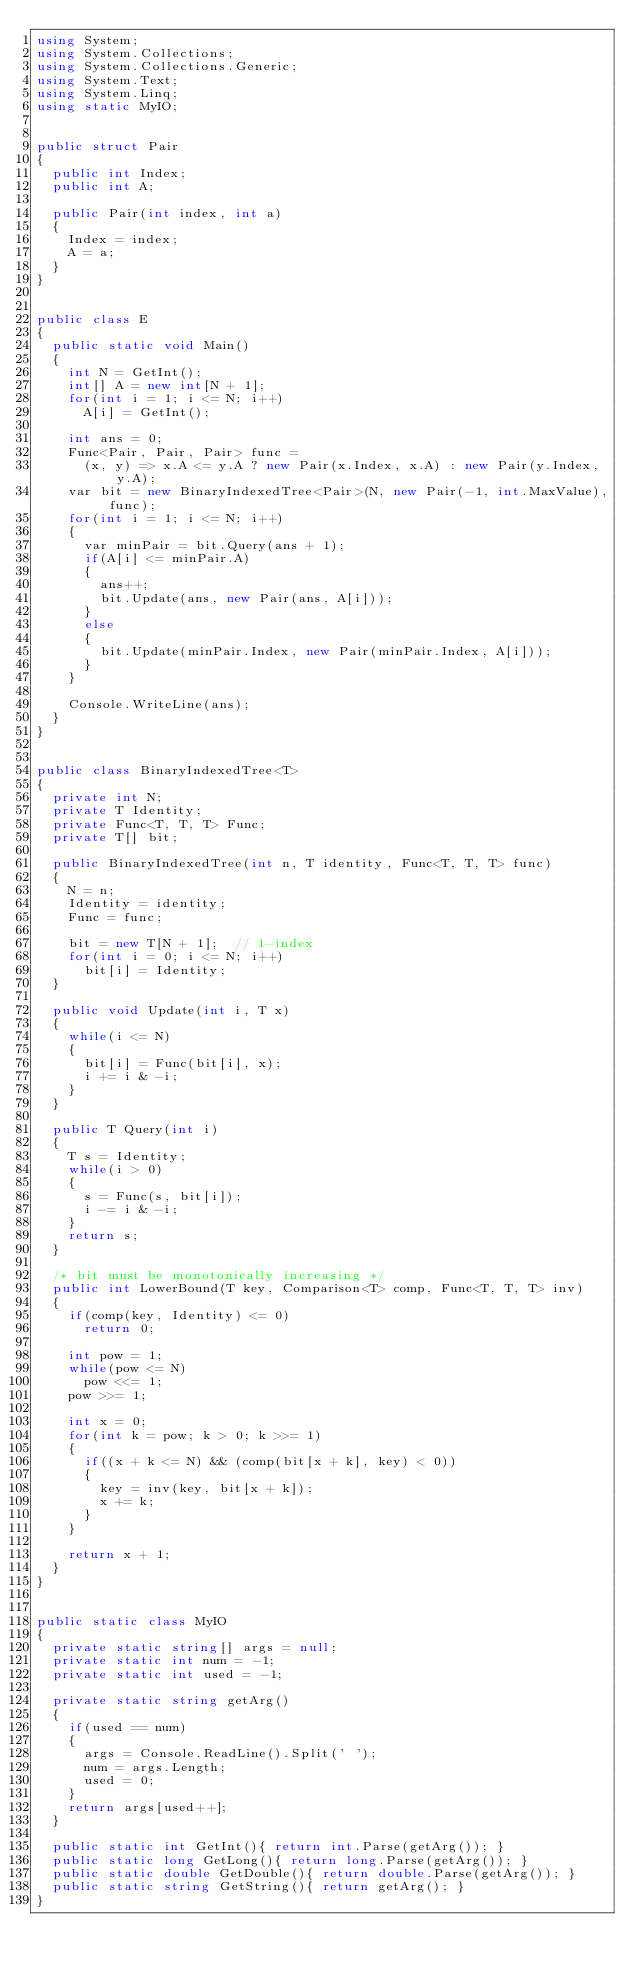Convert code to text. <code><loc_0><loc_0><loc_500><loc_500><_C#_>using System;
using System.Collections;
using System.Collections.Generic;
using System.Text;
using System.Linq;
using static MyIO;


public struct Pair
{
	public int Index;
	public int A;

	public Pair(int index, int a)
	{
		Index = index;
		A = a;
	}
}


public class E
{
	public static void Main()
	{
		int N = GetInt();
		int[] A = new int[N + 1];
		for(int i = 1; i <= N; i++)
			A[i] = GetInt();

		int ans = 0;
		Func<Pair, Pair, Pair> func = 
			(x, y) => x.A <= y.A ? new Pair(x.Index, x.A) : new Pair(y.Index, y.A);
		var bit = new BinaryIndexedTree<Pair>(N, new Pair(-1, int.MaxValue), func);
		for(int i = 1; i <= N; i++)
		{
			var minPair = bit.Query(ans + 1);
			if(A[i] <= minPair.A)
			{
				ans++;
				bit.Update(ans, new Pair(ans, A[i]));
			}
			else
			{
				bit.Update(minPair.Index, new Pair(minPair.Index, A[i]));
			}
		}

		Console.WriteLine(ans);
	}
}


public class BinaryIndexedTree<T>
{
	private int N;
	private T Identity;
	private Func<T, T, T> Func;
	private T[] bit;

	public BinaryIndexedTree(int n, T identity, Func<T, T, T> func)
	{
		N = n;
		Identity = identity;
		Func = func;
			
		bit = new T[N + 1];  // 1-index
		for(int i = 0; i <= N; i++)
			bit[i] = Identity;
	}

	public void Update(int i, T x)
	{
		while(i <= N)
		{
			bit[i] = Func(bit[i], x);
			i += i & -i;
		}
	}

	public T Query(int i)
	{
		T s = Identity;
		while(i > 0)
		{
			s = Func(s, bit[i]);
			i -= i & -i;
		}
		return s;
	}

	/* bit must be monotonically increasing */
	public int LowerBound(T key, Comparison<T> comp, Func<T, T, T> inv)
	{
		if(comp(key, Identity) <= 0)
			return 0;

		int pow = 1;
		while(pow <= N)
			pow <<= 1;
		pow >>= 1;

		int x = 0;
		for(int k = pow; k > 0; k >>= 1)
		{
			if((x + k <= N) && (comp(bit[x + k], key) < 0))
			{
				key = inv(key, bit[x + k]);
				x += k;
			}
		}

		return x + 1;
	}
}


public static class MyIO
{
	private static string[] args = null;
	private static int num = -1;
	private static int used = -1;

	private static string getArg()
	{
		if(used == num)
		{
			args = Console.ReadLine().Split(' ');
			num = args.Length;
			used = 0;
		}
		return args[used++];
	}

	public static int GetInt(){ return int.Parse(getArg()); }
	public static long GetLong(){ return long.Parse(getArg()); }
	public static double GetDouble(){ return double.Parse(getArg()); }
	public static string GetString(){ return getArg(); }
}



</code> 